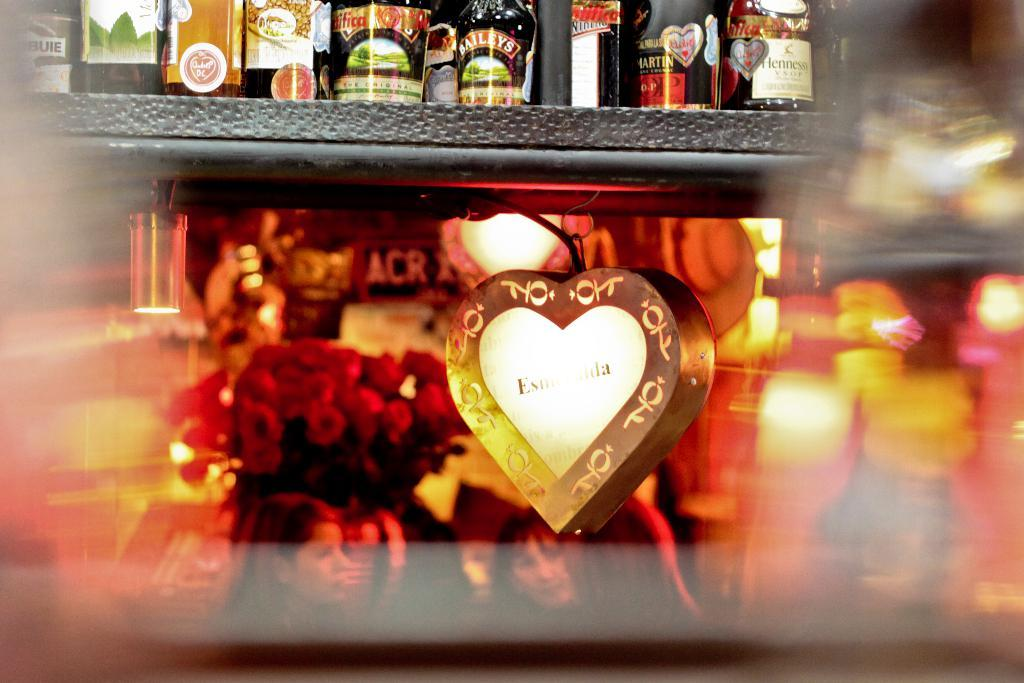What is located at the bottom of the image? There are persons, a flower vase, and decor at the bottom of the image. What can be found on the rack at the top of the image? There are things placed on the rack at the top of the image. What is the purpose of the flower vase at the bottom of the image? The flower vase is likely used for holding flowers as decoration. What is the nature of the decor at the bottom of the image? The decor at the bottom of the image could be any type of ornamentation or design element. How does the heat affect the persons at the bottom of the image? There is no mention of heat in the image, so we cannot determine its effect on the persons. Can you describe the kiss between the persons at the bottom of the image? There is no kiss depicted in the image. What type of land is visible in the image? There is no land visible in the image; it only shows persons, a flower vase, decor, and a rack with things placed on it. 